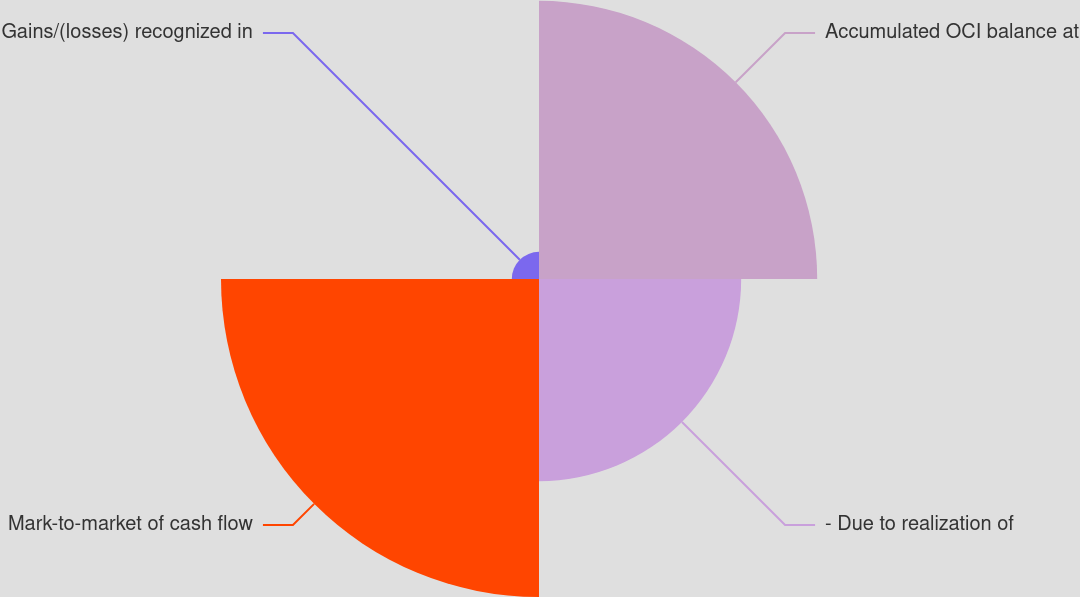Convert chart. <chart><loc_0><loc_0><loc_500><loc_500><pie_chart><fcel>Accumulated OCI balance at<fcel>- Due to realization of<fcel>Mark-to-market of cash flow<fcel>Gains/(losses) recognized in<nl><fcel>33.7%<fcel>24.49%<fcel>38.52%<fcel>3.29%<nl></chart> 